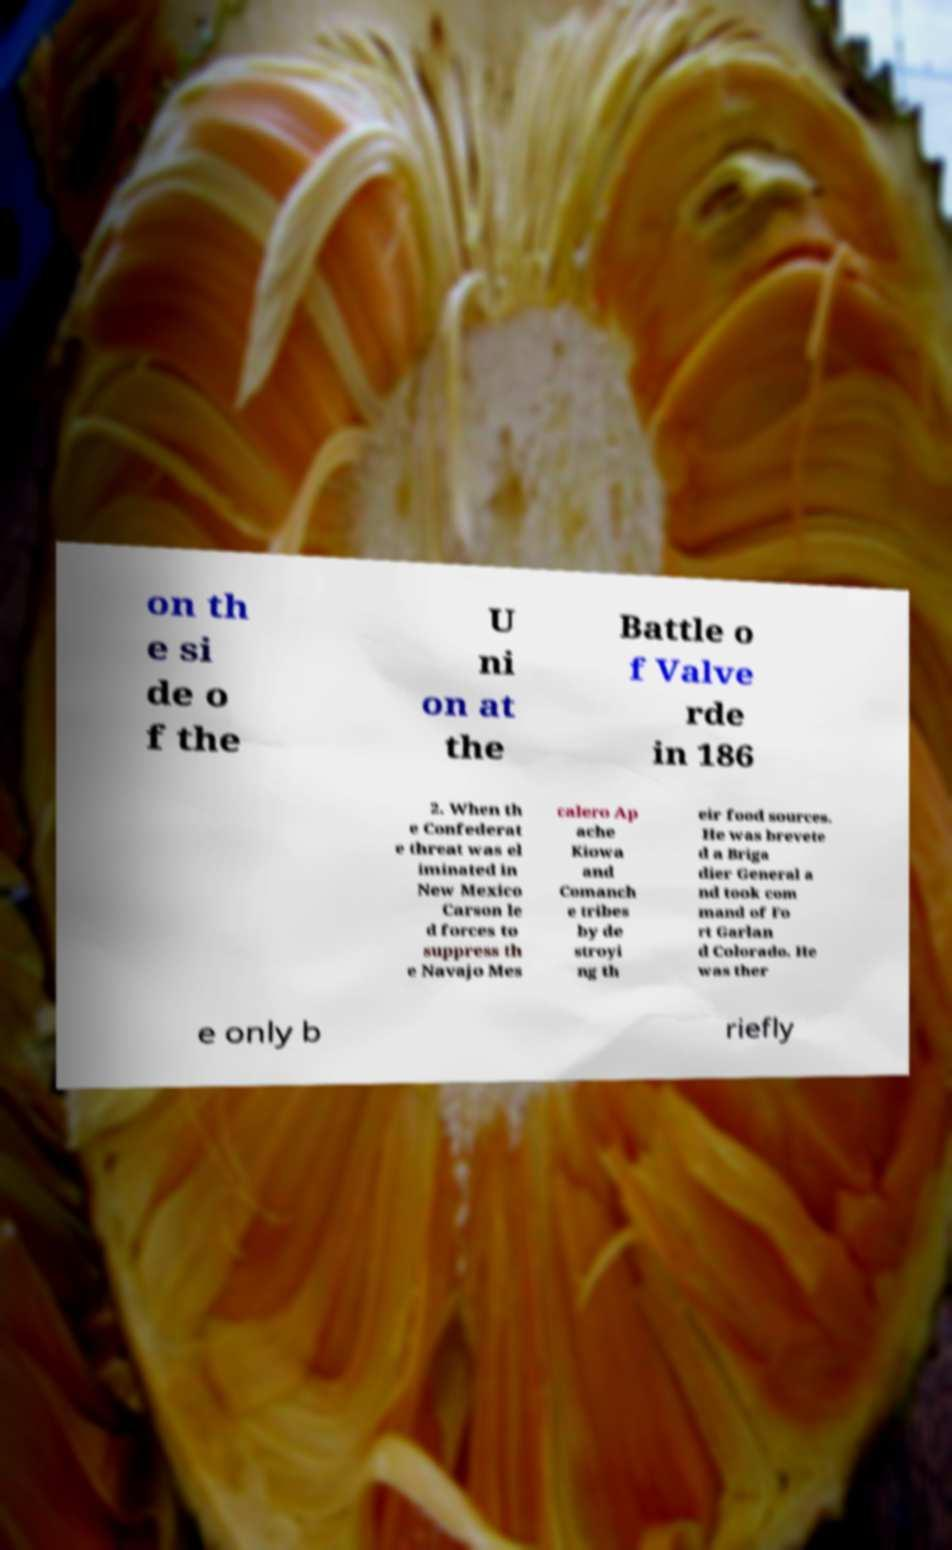What messages or text are displayed in this image? I need them in a readable, typed format. on th e si de o f the U ni on at the Battle o f Valve rde in 186 2. When th e Confederat e threat was el iminated in New Mexico Carson le d forces to suppress th e Navajo Mes calero Ap ache Kiowa and Comanch e tribes by de stroyi ng th eir food sources. He was brevete d a Briga dier General a nd took com mand of Fo rt Garlan d Colorado. He was ther e only b riefly 